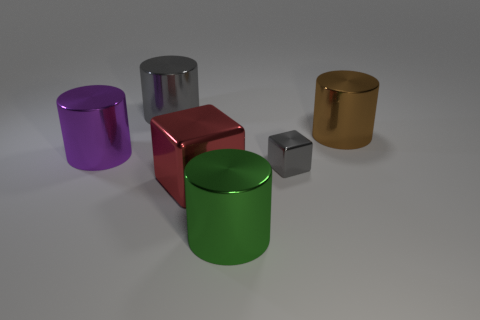Subtract all brown shiny cylinders. How many cylinders are left? 3 Subtract all red blocks. How many blocks are left? 1 Add 3 big red shiny things. How many objects exist? 9 Subtract all blocks. How many objects are left? 4 Subtract 3 cylinders. How many cylinders are left? 1 Subtract all purple cylinders. Subtract all red blocks. How many cylinders are left? 3 Subtract all red balls. How many brown cylinders are left? 1 Subtract all large green metal balls. Subtract all brown shiny objects. How many objects are left? 5 Add 6 gray metal things. How many gray metal things are left? 8 Add 4 purple matte balls. How many purple matte balls exist? 4 